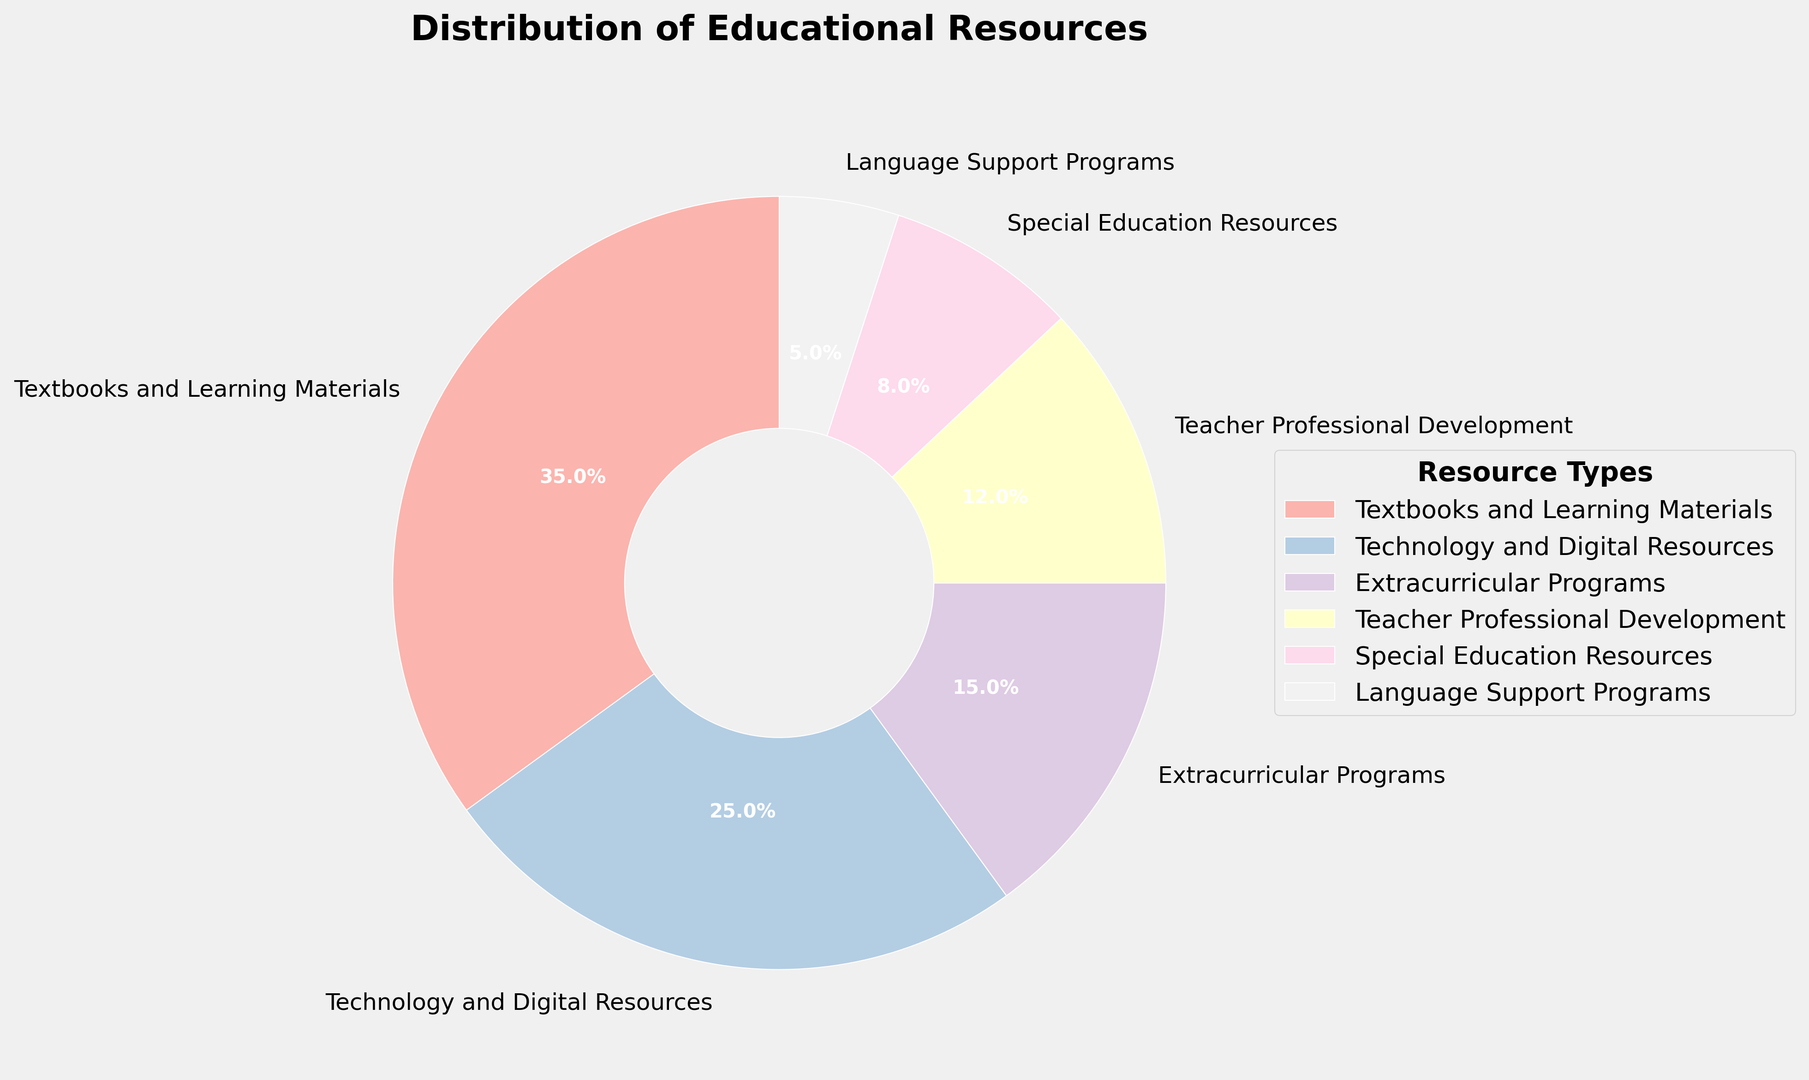Which resource has the highest allocation percentage? The figure shows a pie chart where each slice represents a portion of the total allocation. The largest slice corresponds to "Textbooks and Learning Materials" with 35%.
Answer: Textbooks and Learning Materials Compare the allocation percentages of Technology and Digital Resources and Special Education Resources. Which one is higher and by how much? The pie chart indicates the percentages of different resource types. Technology and Digital Resources are allocated 25%, while Special Education Resources have 8%. The difference is 25% - 8% = 17%.
Answer: Technology and Digital Resources by 17% What is the combined percentage allocation for Teacher Professional Development and Language Support Programs? Add the percentages of Teacher Professional Development (12%) and Language Support Programs (5%) to find the combined total. 12% + 5% = 17%.
Answer: 17% Identify the smallest allocation percentage. Which resource does it correspond to? The pie chart's smallest slice represents the resource with the lowest allocation. This is "Language Support Programs" with 5%.
Answer: Language Support Programs Is the percentage allocation for Extracurricular Programs greater than or less than half of the allocation for Textbooks and Learning Materials? The pie chart provides percentages for each resource type. Half of Textbooks and Learning Materials' 35% is 17.5%. Extracurricular Programs are allocated 15%, which is less than 17.5%.
Answer: Less What percentage of the allocation accounts for resources that directly support teachers (Teacher Professional Development)? The allocation for Teacher Professional Development is given as 12% in the pie chart.
Answer: 12% Calculate the total percentage allocation for resources related to student support (Special Education Resources and Language Support Programs). Add the percentages for Special Education Resources (8%) and Language Support Programs (5%) to find the total allocation. 8% + 5% = 13%.
Answer: 13% How much more is allocated to Textbooks and Learning Materials compared to Language Support Programs? The pie chart shows that Textbooks and Learning Materials have 35%, and Language Support Programs have 5%. The difference is 35% - 5% = 30%.
Answer: 30% Describe the color used for Teacher Professional Development and identify its position relative to other slices. Teacher Professional Development is represented as a segment (slice) with comparisons in color among other mentioned resources. This segment can be identified by finding the color associated with its name and its position in the pie chart.
Answer: Describe using chart colors and positions 